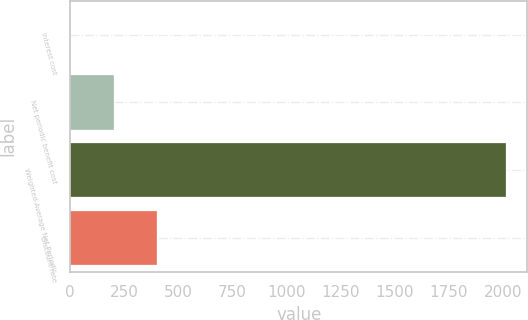<chart> <loc_0><loc_0><loc_500><loc_500><bar_chart><fcel>Interest cost<fcel>Net periodic benefit cost<fcel>Weighted-Average Net Periodic<fcel>Discount rate<nl><fcel>0.3<fcel>201.67<fcel>2014<fcel>403.04<nl></chart> 